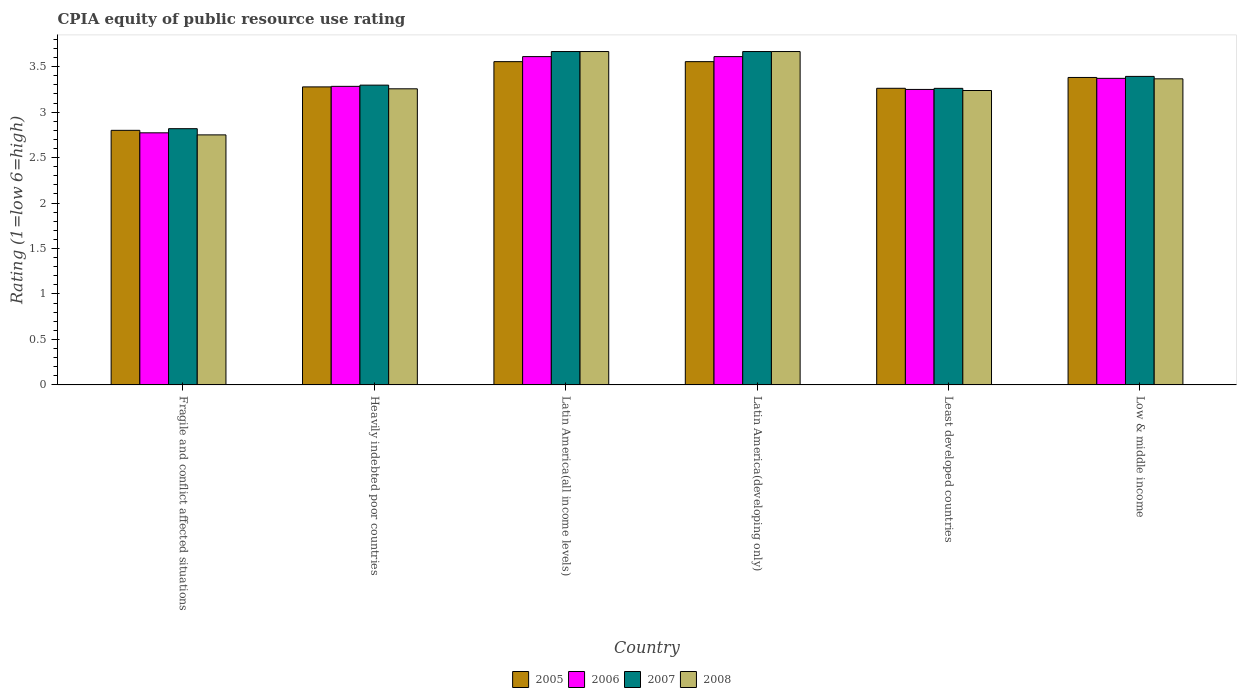How many groups of bars are there?
Give a very brief answer. 6. Are the number of bars per tick equal to the number of legend labels?
Keep it short and to the point. Yes. Are the number of bars on each tick of the X-axis equal?
Keep it short and to the point. Yes. How many bars are there on the 3rd tick from the right?
Ensure brevity in your answer.  4. What is the CPIA rating in 2006 in Latin America(all income levels)?
Your response must be concise. 3.61. Across all countries, what is the maximum CPIA rating in 2008?
Offer a terse response. 3.67. Across all countries, what is the minimum CPIA rating in 2008?
Provide a short and direct response. 2.75. In which country was the CPIA rating in 2006 maximum?
Offer a terse response. Latin America(all income levels). In which country was the CPIA rating in 2007 minimum?
Offer a terse response. Fragile and conflict affected situations. What is the total CPIA rating in 2006 in the graph?
Your answer should be very brief. 19.9. What is the difference between the CPIA rating in 2006 in Fragile and conflict affected situations and that in Least developed countries?
Give a very brief answer. -0.48. What is the difference between the CPIA rating in 2008 in Heavily indebted poor countries and the CPIA rating in 2005 in Fragile and conflict affected situations?
Your response must be concise. 0.46. What is the average CPIA rating in 2005 per country?
Offer a very short reply. 3.31. What is the difference between the CPIA rating of/in 2006 and CPIA rating of/in 2007 in Least developed countries?
Your response must be concise. -0.01. What is the ratio of the CPIA rating in 2008 in Fragile and conflict affected situations to that in Heavily indebted poor countries?
Provide a succinct answer. 0.84. Is the CPIA rating in 2007 in Least developed countries less than that in Low & middle income?
Provide a succinct answer. Yes. What is the difference between the highest and the second highest CPIA rating in 2007?
Make the answer very short. -0.27. What is the difference between the highest and the lowest CPIA rating in 2007?
Keep it short and to the point. 0.85. In how many countries, is the CPIA rating in 2006 greater than the average CPIA rating in 2006 taken over all countries?
Keep it short and to the point. 3. Is the sum of the CPIA rating in 2007 in Heavily indebted poor countries and Latin America(developing only) greater than the maximum CPIA rating in 2005 across all countries?
Your answer should be compact. Yes. What does the 4th bar from the left in Least developed countries represents?
Your answer should be compact. 2008. Does the graph contain grids?
Offer a terse response. No. Where does the legend appear in the graph?
Keep it short and to the point. Bottom center. How many legend labels are there?
Your answer should be very brief. 4. What is the title of the graph?
Ensure brevity in your answer.  CPIA equity of public resource use rating. Does "2012" appear as one of the legend labels in the graph?
Provide a short and direct response. No. What is the label or title of the Y-axis?
Your response must be concise. Rating (1=low 6=high). What is the Rating (1=low 6=high) in 2005 in Fragile and conflict affected situations?
Keep it short and to the point. 2.8. What is the Rating (1=low 6=high) in 2006 in Fragile and conflict affected situations?
Provide a succinct answer. 2.77. What is the Rating (1=low 6=high) in 2007 in Fragile and conflict affected situations?
Your answer should be very brief. 2.82. What is the Rating (1=low 6=high) in 2008 in Fragile and conflict affected situations?
Offer a terse response. 2.75. What is the Rating (1=low 6=high) in 2005 in Heavily indebted poor countries?
Make the answer very short. 3.28. What is the Rating (1=low 6=high) in 2006 in Heavily indebted poor countries?
Your answer should be very brief. 3.28. What is the Rating (1=low 6=high) of 2007 in Heavily indebted poor countries?
Your answer should be very brief. 3.3. What is the Rating (1=low 6=high) of 2008 in Heavily indebted poor countries?
Offer a very short reply. 3.26. What is the Rating (1=low 6=high) in 2005 in Latin America(all income levels)?
Give a very brief answer. 3.56. What is the Rating (1=low 6=high) in 2006 in Latin America(all income levels)?
Offer a very short reply. 3.61. What is the Rating (1=low 6=high) in 2007 in Latin America(all income levels)?
Offer a terse response. 3.67. What is the Rating (1=low 6=high) in 2008 in Latin America(all income levels)?
Keep it short and to the point. 3.67. What is the Rating (1=low 6=high) in 2005 in Latin America(developing only)?
Give a very brief answer. 3.56. What is the Rating (1=low 6=high) of 2006 in Latin America(developing only)?
Offer a terse response. 3.61. What is the Rating (1=low 6=high) of 2007 in Latin America(developing only)?
Give a very brief answer. 3.67. What is the Rating (1=low 6=high) in 2008 in Latin America(developing only)?
Your answer should be compact. 3.67. What is the Rating (1=low 6=high) of 2005 in Least developed countries?
Give a very brief answer. 3.26. What is the Rating (1=low 6=high) in 2006 in Least developed countries?
Give a very brief answer. 3.25. What is the Rating (1=low 6=high) of 2007 in Least developed countries?
Your response must be concise. 3.26. What is the Rating (1=low 6=high) in 2008 in Least developed countries?
Your response must be concise. 3.24. What is the Rating (1=low 6=high) in 2005 in Low & middle income?
Make the answer very short. 3.38. What is the Rating (1=low 6=high) of 2006 in Low & middle income?
Your answer should be very brief. 3.37. What is the Rating (1=low 6=high) in 2007 in Low & middle income?
Your response must be concise. 3.39. What is the Rating (1=low 6=high) of 2008 in Low & middle income?
Offer a very short reply. 3.37. Across all countries, what is the maximum Rating (1=low 6=high) in 2005?
Offer a terse response. 3.56. Across all countries, what is the maximum Rating (1=low 6=high) of 2006?
Your answer should be very brief. 3.61. Across all countries, what is the maximum Rating (1=low 6=high) in 2007?
Your answer should be very brief. 3.67. Across all countries, what is the maximum Rating (1=low 6=high) in 2008?
Give a very brief answer. 3.67. Across all countries, what is the minimum Rating (1=low 6=high) in 2006?
Keep it short and to the point. 2.77. Across all countries, what is the minimum Rating (1=low 6=high) of 2007?
Keep it short and to the point. 2.82. Across all countries, what is the minimum Rating (1=low 6=high) of 2008?
Ensure brevity in your answer.  2.75. What is the total Rating (1=low 6=high) of 2005 in the graph?
Keep it short and to the point. 19.83. What is the total Rating (1=low 6=high) of 2006 in the graph?
Ensure brevity in your answer.  19.9. What is the total Rating (1=low 6=high) of 2007 in the graph?
Provide a short and direct response. 20.1. What is the total Rating (1=low 6=high) of 2008 in the graph?
Keep it short and to the point. 19.94. What is the difference between the Rating (1=low 6=high) of 2005 in Fragile and conflict affected situations and that in Heavily indebted poor countries?
Your answer should be compact. -0.48. What is the difference between the Rating (1=low 6=high) of 2006 in Fragile and conflict affected situations and that in Heavily indebted poor countries?
Offer a terse response. -0.51. What is the difference between the Rating (1=low 6=high) of 2007 in Fragile and conflict affected situations and that in Heavily indebted poor countries?
Offer a very short reply. -0.48. What is the difference between the Rating (1=low 6=high) in 2008 in Fragile and conflict affected situations and that in Heavily indebted poor countries?
Offer a very short reply. -0.51. What is the difference between the Rating (1=low 6=high) of 2005 in Fragile and conflict affected situations and that in Latin America(all income levels)?
Your response must be concise. -0.76. What is the difference between the Rating (1=low 6=high) in 2006 in Fragile and conflict affected situations and that in Latin America(all income levels)?
Offer a terse response. -0.84. What is the difference between the Rating (1=low 6=high) in 2007 in Fragile and conflict affected situations and that in Latin America(all income levels)?
Your response must be concise. -0.85. What is the difference between the Rating (1=low 6=high) of 2008 in Fragile and conflict affected situations and that in Latin America(all income levels)?
Your response must be concise. -0.92. What is the difference between the Rating (1=low 6=high) of 2005 in Fragile and conflict affected situations and that in Latin America(developing only)?
Your answer should be very brief. -0.76. What is the difference between the Rating (1=low 6=high) of 2006 in Fragile and conflict affected situations and that in Latin America(developing only)?
Give a very brief answer. -0.84. What is the difference between the Rating (1=low 6=high) of 2007 in Fragile and conflict affected situations and that in Latin America(developing only)?
Offer a very short reply. -0.85. What is the difference between the Rating (1=low 6=high) in 2008 in Fragile and conflict affected situations and that in Latin America(developing only)?
Offer a very short reply. -0.92. What is the difference between the Rating (1=low 6=high) in 2005 in Fragile and conflict affected situations and that in Least developed countries?
Offer a very short reply. -0.46. What is the difference between the Rating (1=low 6=high) in 2006 in Fragile and conflict affected situations and that in Least developed countries?
Provide a short and direct response. -0.48. What is the difference between the Rating (1=low 6=high) of 2007 in Fragile and conflict affected situations and that in Least developed countries?
Keep it short and to the point. -0.44. What is the difference between the Rating (1=low 6=high) in 2008 in Fragile and conflict affected situations and that in Least developed countries?
Your answer should be compact. -0.49. What is the difference between the Rating (1=low 6=high) in 2005 in Fragile and conflict affected situations and that in Low & middle income?
Your answer should be very brief. -0.58. What is the difference between the Rating (1=low 6=high) in 2006 in Fragile and conflict affected situations and that in Low & middle income?
Provide a short and direct response. -0.6. What is the difference between the Rating (1=low 6=high) in 2007 in Fragile and conflict affected situations and that in Low & middle income?
Offer a very short reply. -0.58. What is the difference between the Rating (1=low 6=high) of 2008 in Fragile and conflict affected situations and that in Low & middle income?
Provide a succinct answer. -0.62. What is the difference between the Rating (1=low 6=high) of 2005 in Heavily indebted poor countries and that in Latin America(all income levels)?
Your answer should be very brief. -0.28. What is the difference between the Rating (1=low 6=high) in 2006 in Heavily indebted poor countries and that in Latin America(all income levels)?
Your answer should be very brief. -0.33. What is the difference between the Rating (1=low 6=high) of 2007 in Heavily indebted poor countries and that in Latin America(all income levels)?
Offer a terse response. -0.37. What is the difference between the Rating (1=low 6=high) in 2008 in Heavily indebted poor countries and that in Latin America(all income levels)?
Your answer should be very brief. -0.41. What is the difference between the Rating (1=low 6=high) of 2005 in Heavily indebted poor countries and that in Latin America(developing only)?
Offer a very short reply. -0.28. What is the difference between the Rating (1=low 6=high) in 2006 in Heavily indebted poor countries and that in Latin America(developing only)?
Your answer should be very brief. -0.33. What is the difference between the Rating (1=low 6=high) in 2007 in Heavily indebted poor countries and that in Latin America(developing only)?
Keep it short and to the point. -0.37. What is the difference between the Rating (1=low 6=high) in 2008 in Heavily indebted poor countries and that in Latin America(developing only)?
Offer a terse response. -0.41. What is the difference between the Rating (1=low 6=high) in 2005 in Heavily indebted poor countries and that in Least developed countries?
Offer a very short reply. 0.02. What is the difference between the Rating (1=low 6=high) in 2006 in Heavily indebted poor countries and that in Least developed countries?
Your answer should be very brief. 0.03. What is the difference between the Rating (1=low 6=high) in 2007 in Heavily indebted poor countries and that in Least developed countries?
Your response must be concise. 0.04. What is the difference between the Rating (1=low 6=high) of 2008 in Heavily indebted poor countries and that in Least developed countries?
Give a very brief answer. 0.02. What is the difference between the Rating (1=low 6=high) in 2005 in Heavily indebted poor countries and that in Low & middle income?
Provide a short and direct response. -0.1. What is the difference between the Rating (1=low 6=high) in 2006 in Heavily indebted poor countries and that in Low & middle income?
Offer a very short reply. -0.09. What is the difference between the Rating (1=low 6=high) in 2007 in Heavily indebted poor countries and that in Low & middle income?
Offer a terse response. -0.1. What is the difference between the Rating (1=low 6=high) of 2008 in Heavily indebted poor countries and that in Low & middle income?
Your answer should be compact. -0.11. What is the difference between the Rating (1=low 6=high) in 2005 in Latin America(all income levels) and that in Latin America(developing only)?
Offer a terse response. 0. What is the difference between the Rating (1=low 6=high) of 2006 in Latin America(all income levels) and that in Latin America(developing only)?
Offer a very short reply. 0. What is the difference between the Rating (1=low 6=high) of 2007 in Latin America(all income levels) and that in Latin America(developing only)?
Your answer should be very brief. 0. What is the difference between the Rating (1=low 6=high) in 2005 in Latin America(all income levels) and that in Least developed countries?
Provide a short and direct response. 0.29. What is the difference between the Rating (1=low 6=high) of 2006 in Latin America(all income levels) and that in Least developed countries?
Provide a succinct answer. 0.36. What is the difference between the Rating (1=low 6=high) in 2007 in Latin America(all income levels) and that in Least developed countries?
Offer a terse response. 0.4. What is the difference between the Rating (1=low 6=high) of 2008 in Latin America(all income levels) and that in Least developed countries?
Give a very brief answer. 0.43. What is the difference between the Rating (1=low 6=high) in 2005 in Latin America(all income levels) and that in Low & middle income?
Keep it short and to the point. 0.17. What is the difference between the Rating (1=low 6=high) of 2006 in Latin America(all income levels) and that in Low & middle income?
Your response must be concise. 0.24. What is the difference between the Rating (1=low 6=high) in 2007 in Latin America(all income levels) and that in Low & middle income?
Your response must be concise. 0.27. What is the difference between the Rating (1=low 6=high) of 2008 in Latin America(all income levels) and that in Low & middle income?
Provide a succinct answer. 0.3. What is the difference between the Rating (1=low 6=high) in 2005 in Latin America(developing only) and that in Least developed countries?
Provide a short and direct response. 0.29. What is the difference between the Rating (1=low 6=high) in 2006 in Latin America(developing only) and that in Least developed countries?
Give a very brief answer. 0.36. What is the difference between the Rating (1=low 6=high) of 2007 in Latin America(developing only) and that in Least developed countries?
Ensure brevity in your answer.  0.4. What is the difference between the Rating (1=low 6=high) in 2008 in Latin America(developing only) and that in Least developed countries?
Your answer should be compact. 0.43. What is the difference between the Rating (1=low 6=high) in 2005 in Latin America(developing only) and that in Low & middle income?
Offer a very short reply. 0.17. What is the difference between the Rating (1=low 6=high) in 2006 in Latin America(developing only) and that in Low & middle income?
Your answer should be very brief. 0.24. What is the difference between the Rating (1=low 6=high) in 2007 in Latin America(developing only) and that in Low & middle income?
Your answer should be very brief. 0.27. What is the difference between the Rating (1=low 6=high) of 2008 in Latin America(developing only) and that in Low & middle income?
Ensure brevity in your answer.  0.3. What is the difference between the Rating (1=low 6=high) in 2005 in Least developed countries and that in Low & middle income?
Your answer should be compact. -0.12. What is the difference between the Rating (1=low 6=high) of 2006 in Least developed countries and that in Low & middle income?
Keep it short and to the point. -0.12. What is the difference between the Rating (1=low 6=high) in 2007 in Least developed countries and that in Low & middle income?
Offer a terse response. -0.13. What is the difference between the Rating (1=low 6=high) of 2008 in Least developed countries and that in Low & middle income?
Keep it short and to the point. -0.13. What is the difference between the Rating (1=low 6=high) in 2005 in Fragile and conflict affected situations and the Rating (1=low 6=high) in 2006 in Heavily indebted poor countries?
Offer a terse response. -0.48. What is the difference between the Rating (1=low 6=high) in 2005 in Fragile and conflict affected situations and the Rating (1=low 6=high) in 2007 in Heavily indebted poor countries?
Ensure brevity in your answer.  -0.5. What is the difference between the Rating (1=low 6=high) in 2005 in Fragile and conflict affected situations and the Rating (1=low 6=high) in 2008 in Heavily indebted poor countries?
Offer a very short reply. -0.46. What is the difference between the Rating (1=low 6=high) of 2006 in Fragile and conflict affected situations and the Rating (1=low 6=high) of 2007 in Heavily indebted poor countries?
Make the answer very short. -0.52. What is the difference between the Rating (1=low 6=high) of 2006 in Fragile and conflict affected situations and the Rating (1=low 6=high) of 2008 in Heavily indebted poor countries?
Keep it short and to the point. -0.48. What is the difference between the Rating (1=low 6=high) of 2007 in Fragile and conflict affected situations and the Rating (1=low 6=high) of 2008 in Heavily indebted poor countries?
Provide a succinct answer. -0.44. What is the difference between the Rating (1=low 6=high) of 2005 in Fragile and conflict affected situations and the Rating (1=low 6=high) of 2006 in Latin America(all income levels)?
Keep it short and to the point. -0.81. What is the difference between the Rating (1=low 6=high) in 2005 in Fragile and conflict affected situations and the Rating (1=low 6=high) in 2007 in Latin America(all income levels)?
Make the answer very short. -0.87. What is the difference between the Rating (1=low 6=high) of 2005 in Fragile and conflict affected situations and the Rating (1=low 6=high) of 2008 in Latin America(all income levels)?
Make the answer very short. -0.87. What is the difference between the Rating (1=low 6=high) in 2006 in Fragile and conflict affected situations and the Rating (1=low 6=high) in 2007 in Latin America(all income levels)?
Make the answer very short. -0.89. What is the difference between the Rating (1=low 6=high) in 2006 in Fragile and conflict affected situations and the Rating (1=low 6=high) in 2008 in Latin America(all income levels)?
Your answer should be very brief. -0.89. What is the difference between the Rating (1=low 6=high) in 2007 in Fragile and conflict affected situations and the Rating (1=low 6=high) in 2008 in Latin America(all income levels)?
Provide a short and direct response. -0.85. What is the difference between the Rating (1=low 6=high) in 2005 in Fragile and conflict affected situations and the Rating (1=low 6=high) in 2006 in Latin America(developing only)?
Keep it short and to the point. -0.81. What is the difference between the Rating (1=low 6=high) of 2005 in Fragile and conflict affected situations and the Rating (1=low 6=high) of 2007 in Latin America(developing only)?
Provide a short and direct response. -0.87. What is the difference between the Rating (1=low 6=high) in 2005 in Fragile and conflict affected situations and the Rating (1=low 6=high) in 2008 in Latin America(developing only)?
Give a very brief answer. -0.87. What is the difference between the Rating (1=low 6=high) in 2006 in Fragile and conflict affected situations and the Rating (1=low 6=high) in 2007 in Latin America(developing only)?
Give a very brief answer. -0.89. What is the difference between the Rating (1=low 6=high) in 2006 in Fragile and conflict affected situations and the Rating (1=low 6=high) in 2008 in Latin America(developing only)?
Make the answer very short. -0.89. What is the difference between the Rating (1=low 6=high) of 2007 in Fragile and conflict affected situations and the Rating (1=low 6=high) of 2008 in Latin America(developing only)?
Provide a succinct answer. -0.85. What is the difference between the Rating (1=low 6=high) in 2005 in Fragile and conflict affected situations and the Rating (1=low 6=high) in 2006 in Least developed countries?
Ensure brevity in your answer.  -0.45. What is the difference between the Rating (1=low 6=high) in 2005 in Fragile and conflict affected situations and the Rating (1=low 6=high) in 2007 in Least developed countries?
Your answer should be compact. -0.46. What is the difference between the Rating (1=low 6=high) in 2005 in Fragile and conflict affected situations and the Rating (1=low 6=high) in 2008 in Least developed countries?
Give a very brief answer. -0.44. What is the difference between the Rating (1=low 6=high) of 2006 in Fragile and conflict affected situations and the Rating (1=low 6=high) of 2007 in Least developed countries?
Offer a very short reply. -0.49. What is the difference between the Rating (1=low 6=high) of 2006 in Fragile and conflict affected situations and the Rating (1=low 6=high) of 2008 in Least developed countries?
Keep it short and to the point. -0.47. What is the difference between the Rating (1=low 6=high) in 2007 in Fragile and conflict affected situations and the Rating (1=low 6=high) in 2008 in Least developed countries?
Give a very brief answer. -0.42. What is the difference between the Rating (1=low 6=high) of 2005 in Fragile and conflict affected situations and the Rating (1=low 6=high) of 2006 in Low & middle income?
Your answer should be compact. -0.57. What is the difference between the Rating (1=low 6=high) in 2005 in Fragile and conflict affected situations and the Rating (1=low 6=high) in 2007 in Low & middle income?
Your answer should be very brief. -0.59. What is the difference between the Rating (1=low 6=high) in 2005 in Fragile and conflict affected situations and the Rating (1=low 6=high) in 2008 in Low & middle income?
Make the answer very short. -0.57. What is the difference between the Rating (1=low 6=high) of 2006 in Fragile and conflict affected situations and the Rating (1=low 6=high) of 2007 in Low & middle income?
Make the answer very short. -0.62. What is the difference between the Rating (1=low 6=high) of 2006 in Fragile and conflict affected situations and the Rating (1=low 6=high) of 2008 in Low & middle income?
Your answer should be compact. -0.59. What is the difference between the Rating (1=low 6=high) in 2007 in Fragile and conflict affected situations and the Rating (1=low 6=high) in 2008 in Low & middle income?
Offer a terse response. -0.55. What is the difference between the Rating (1=low 6=high) in 2005 in Heavily indebted poor countries and the Rating (1=low 6=high) in 2007 in Latin America(all income levels)?
Offer a terse response. -0.39. What is the difference between the Rating (1=low 6=high) in 2005 in Heavily indebted poor countries and the Rating (1=low 6=high) in 2008 in Latin America(all income levels)?
Provide a short and direct response. -0.39. What is the difference between the Rating (1=low 6=high) in 2006 in Heavily indebted poor countries and the Rating (1=low 6=high) in 2007 in Latin America(all income levels)?
Offer a very short reply. -0.38. What is the difference between the Rating (1=low 6=high) in 2006 in Heavily indebted poor countries and the Rating (1=low 6=high) in 2008 in Latin America(all income levels)?
Your response must be concise. -0.38. What is the difference between the Rating (1=low 6=high) in 2007 in Heavily indebted poor countries and the Rating (1=low 6=high) in 2008 in Latin America(all income levels)?
Provide a short and direct response. -0.37. What is the difference between the Rating (1=low 6=high) of 2005 in Heavily indebted poor countries and the Rating (1=low 6=high) of 2007 in Latin America(developing only)?
Provide a succinct answer. -0.39. What is the difference between the Rating (1=low 6=high) in 2005 in Heavily indebted poor countries and the Rating (1=low 6=high) in 2008 in Latin America(developing only)?
Your answer should be compact. -0.39. What is the difference between the Rating (1=low 6=high) of 2006 in Heavily indebted poor countries and the Rating (1=low 6=high) of 2007 in Latin America(developing only)?
Keep it short and to the point. -0.38. What is the difference between the Rating (1=low 6=high) of 2006 in Heavily indebted poor countries and the Rating (1=low 6=high) of 2008 in Latin America(developing only)?
Keep it short and to the point. -0.38. What is the difference between the Rating (1=low 6=high) in 2007 in Heavily indebted poor countries and the Rating (1=low 6=high) in 2008 in Latin America(developing only)?
Provide a short and direct response. -0.37. What is the difference between the Rating (1=low 6=high) of 2005 in Heavily indebted poor countries and the Rating (1=low 6=high) of 2006 in Least developed countries?
Keep it short and to the point. 0.03. What is the difference between the Rating (1=low 6=high) in 2005 in Heavily indebted poor countries and the Rating (1=low 6=high) in 2007 in Least developed countries?
Give a very brief answer. 0.02. What is the difference between the Rating (1=low 6=high) in 2005 in Heavily indebted poor countries and the Rating (1=low 6=high) in 2008 in Least developed countries?
Your response must be concise. 0.04. What is the difference between the Rating (1=low 6=high) of 2006 in Heavily indebted poor countries and the Rating (1=low 6=high) of 2007 in Least developed countries?
Make the answer very short. 0.02. What is the difference between the Rating (1=low 6=high) in 2006 in Heavily indebted poor countries and the Rating (1=low 6=high) in 2008 in Least developed countries?
Offer a terse response. 0.05. What is the difference between the Rating (1=low 6=high) of 2007 in Heavily indebted poor countries and the Rating (1=low 6=high) of 2008 in Least developed countries?
Keep it short and to the point. 0.06. What is the difference between the Rating (1=low 6=high) of 2005 in Heavily indebted poor countries and the Rating (1=low 6=high) of 2006 in Low & middle income?
Give a very brief answer. -0.09. What is the difference between the Rating (1=low 6=high) in 2005 in Heavily indebted poor countries and the Rating (1=low 6=high) in 2007 in Low & middle income?
Provide a short and direct response. -0.12. What is the difference between the Rating (1=low 6=high) of 2005 in Heavily indebted poor countries and the Rating (1=low 6=high) of 2008 in Low & middle income?
Ensure brevity in your answer.  -0.09. What is the difference between the Rating (1=low 6=high) in 2006 in Heavily indebted poor countries and the Rating (1=low 6=high) in 2007 in Low & middle income?
Provide a succinct answer. -0.11. What is the difference between the Rating (1=low 6=high) of 2006 in Heavily indebted poor countries and the Rating (1=low 6=high) of 2008 in Low & middle income?
Your answer should be very brief. -0.08. What is the difference between the Rating (1=low 6=high) of 2007 in Heavily indebted poor countries and the Rating (1=low 6=high) of 2008 in Low & middle income?
Offer a very short reply. -0.07. What is the difference between the Rating (1=low 6=high) of 2005 in Latin America(all income levels) and the Rating (1=low 6=high) of 2006 in Latin America(developing only)?
Keep it short and to the point. -0.06. What is the difference between the Rating (1=low 6=high) of 2005 in Latin America(all income levels) and the Rating (1=low 6=high) of 2007 in Latin America(developing only)?
Offer a very short reply. -0.11. What is the difference between the Rating (1=low 6=high) in 2005 in Latin America(all income levels) and the Rating (1=low 6=high) in 2008 in Latin America(developing only)?
Keep it short and to the point. -0.11. What is the difference between the Rating (1=low 6=high) in 2006 in Latin America(all income levels) and the Rating (1=low 6=high) in 2007 in Latin America(developing only)?
Ensure brevity in your answer.  -0.06. What is the difference between the Rating (1=low 6=high) of 2006 in Latin America(all income levels) and the Rating (1=low 6=high) of 2008 in Latin America(developing only)?
Your response must be concise. -0.06. What is the difference between the Rating (1=low 6=high) in 2007 in Latin America(all income levels) and the Rating (1=low 6=high) in 2008 in Latin America(developing only)?
Ensure brevity in your answer.  0. What is the difference between the Rating (1=low 6=high) in 2005 in Latin America(all income levels) and the Rating (1=low 6=high) in 2006 in Least developed countries?
Your answer should be very brief. 0.31. What is the difference between the Rating (1=low 6=high) in 2005 in Latin America(all income levels) and the Rating (1=low 6=high) in 2007 in Least developed countries?
Your answer should be very brief. 0.29. What is the difference between the Rating (1=low 6=high) in 2005 in Latin America(all income levels) and the Rating (1=low 6=high) in 2008 in Least developed countries?
Offer a very short reply. 0.32. What is the difference between the Rating (1=low 6=high) in 2006 in Latin America(all income levels) and the Rating (1=low 6=high) in 2007 in Least developed countries?
Your answer should be compact. 0.35. What is the difference between the Rating (1=low 6=high) of 2006 in Latin America(all income levels) and the Rating (1=low 6=high) of 2008 in Least developed countries?
Provide a succinct answer. 0.37. What is the difference between the Rating (1=low 6=high) of 2007 in Latin America(all income levels) and the Rating (1=low 6=high) of 2008 in Least developed countries?
Make the answer very short. 0.43. What is the difference between the Rating (1=low 6=high) in 2005 in Latin America(all income levels) and the Rating (1=low 6=high) in 2006 in Low & middle income?
Your answer should be compact. 0.18. What is the difference between the Rating (1=low 6=high) of 2005 in Latin America(all income levels) and the Rating (1=low 6=high) of 2007 in Low & middle income?
Your answer should be compact. 0.16. What is the difference between the Rating (1=low 6=high) of 2005 in Latin America(all income levels) and the Rating (1=low 6=high) of 2008 in Low & middle income?
Your answer should be very brief. 0.19. What is the difference between the Rating (1=low 6=high) in 2006 in Latin America(all income levels) and the Rating (1=low 6=high) in 2007 in Low & middle income?
Your answer should be very brief. 0.22. What is the difference between the Rating (1=low 6=high) in 2006 in Latin America(all income levels) and the Rating (1=low 6=high) in 2008 in Low & middle income?
Offer a very short reply. 0.24. What is the difference between the Rating (1=low 6=high) of 2005 in Latin America(developing only) and the Rating (1=low 6=high) of 2006 in Least developed countries?
Offer a terse response. 0.31. What is the difference between the Rating (1=low 6=high) of 2005 in Latin America(developing only) and the Rating (1=low 6=high) of 2007 in Least developed countries?
Ensure brevity in your answer.  0.29. What is the difference between the Rating (1=low 6=high) of 2005 in Latin America(developing only) and the Rating (1=low 6=high) of 2008 in Least developed countries?
Ensure brevity in your answer.  0.32. What is the difference between the Rating (1=low 6=high) of 2006 in Latin America(developing only) and the Rating (1=low 6=high) of 2007 in Least developed countries?
Your answer should be compact. 0.35. What is the difference between the Rating (1=low 6=high) of 2006 in Latin America(developing only) and the Rating (1=low 6=high) of 2008 in Least developed countries?
Offer a very short reply. 0.37. What is the difference between the Rating (1=low 6=high) of 2007 in Latin America(developing only) and the Rating (1=low 6=high) of 2008 in Least developed countries?
Keep it short and to the point. 0.43. What is the difference between the Rating (1=low 6=high) in 2005 in Latin America(developing only) and the Rating (1=low 6=high) in 2006 in Low & middle income?
Your answer should be compact. 0.18. What is the difference between the Rating (1=low 6=high) in 2005 in Latin America(developing only) and the Rating (1=low 6=high) in 2007 in Low & middle income?
Ensure brevity in your answer.  0.16. What is the difference between the Rating (1=low 6=high) of 2005 in Latin America(developing only) and the Rating (1=low 6=high) of 2008 in Low & middle income?
Offer a terse response. 0.19. What is the difference between the Rating (1=low 6=high) of 2006 in Latin America(developing only) and the Rating (1=low 6=high) of 2007 in Low & middle income?
Offer a very short reply. 0.22. What is the difference between the Rating (1=low 6=high) in 2006 in Latin America(developing only) and the Rating (1=low 6=high) in 2008 in Low & middle income?
Your answer should be very brief. 0.24. What is the difference between the Rating (1=low 6=high) of 2007 in Latin America(developing only) and the Rating (1=low 6=high) of 2008 in Low & middle income?
Make the answer very short. 0.3. What is the difference between the Rating (1=low 6=high) in 2005 in Least developed countries and the Rating (1=low 6=high) in 2006 in Low & middle income?
Offer a terse response. -0.11. What is the difference between the Rating (1=low 6=high) in 2005 in Least developed countries and the Rating (1=low 6=high) in 2007 in Low & middle income?
Your answer should be compact. -0.13. What is the difference between the Rating (1=low 6=high) in 2005 in Least developed countries and the Rating (1=low 6=high) in 2008 in Low & middle income?
Your answer should be very brief. -0.1. What is the difference between the Rating (1=low 6=high) in 2006 in Least developed countries and the Rating (1=low 6=high) in 2007 in Low & middle income?
Provide a short and direct response. -0.14. What is the difference between the Rating (1=low 6=high) of 2006 in Least developed countries and the Rating (1=low 6=high) of 2008 in Low & middle income?
Your answer should be compact. -0.12. What is the difference between the Rating (1=low 6=high) of 2007 in Least developed countries and the Rating (1=low 6=high) of 2008 in Low & middle income?
Make the answer very short. -0.1. What is the average Rating (1=low 6=high) of 2005 per country?
Offer a very short reply. 3.31. What is the average Rating (1=low 6=high) of 2006 per country?
Offer a very short reply. 3.32. What is the average Rating (1=low 6=high) of 2007 per country?
Make the answer very short. 3.35. What is the average Rating (1=low 6=high) of 2008 per country?
Provide a succinct answer. 3.32. What is the difference between the Rating (1=low 6=high) in 2005 and Rating (1=low 6=high) in 2006 in Fragile and conflict affected situations?
Your response must be concise. 0.03. What is the difference between the Rating (1=low 6=high) of 2005 and Rating (1=low 6=high) of 2007 in Fragile and conflict affected situations?
Make the answer very short. -0.02. What is the difference between the Rating (1=low 6=high) of 2005 and Rating (1=low 6=high) of 2008 in Fragile and conflict affected situations?
Offer a terse response. 0.05. What is the difference between the Rating (1=low 6=high) of 2006 and Rating (1=low 6=high) of 2007 in Fragile and conflict affected situations?
Offer a very short reply. -0.05. What is the difference between the Rating (1=low 6=high) of 2006 and Rating (1=low 6=high) of 2008 in Fragile and conflict affected situations?
Provide a succinct answer. 0.02. What is the difference between the Rating (1=low 6=high) in 2007 and Rating (1=low 6=high) in 2008 in Fragile and conflict affected situations?
Your answer should be compact. 0.07. What is the difference between the Rating (1=low 6=high) of 2005 and Rating (1=low 6=high) of 2006 in Heavily indebted poor countries?
Ensure brevity in your answer.  -0.01. What is the difference between the Rating (1=low 6=high) of 2005 and Rating (1=low 6=high) of 2007 in Heavily indebted poor countries?
Your answer should be very brief. -0.02. What is the difference between the Rating (1=low 6=high) of 2005 and Rating (1=low 6=high) of 2008 in Heavily indebted poor countries?
Your response must be concise. 0.02. What is the difference between the Rating (1=low 6=high) in 2006 and Rating (1=low 6=high) in 2007 in Heavily indebted poor countries?
Give a very brief answer. -0.01. What is the difference between the Rating (1=low 6=high) in 2006 and Rating (1=low 6=high) in 2008 in Heavily indebted poor countries?
Your response must be concise. 0.03. What is the difference between the Rating (1=low 6=high) of 2007 and Rating (1=low 6=high) of 2008 in Heavily indebted poor countries?
Offer a terse response. 0.04. What is the difference between the Rating (1=low 6=high) in 2005 and Rating (1=low 6=high) in 2006 in Latin America(all income levels)?
Provide a succinct answer. -0.06. What is the difference between the Rating (1=low 6=high) in 2005 and Rating (1=low 6=high) in 2007 in Latin America(all income levels)?
Offer a very short reply. -0.11. What is the difference between the Rating (1=low 6=high) in 2005 and Rating (1=low 6=high) in 2008 in Latin America(all income levels)?
Give a very brief answer. -0.11. What is the difference between the Rating (1=low 6=high) of 2006 and Rating (1=low 6=high) of 2007 in Latin America(all income levels)?
Your answer should be very brief. -0.06. What is the difference between the Rating (1=low 6=high) in 2006 and Rating (1=low 6=high) in 2008 in Latin America(all income levels)?
Your answer should be compact. -0.06. What is the difference between the Rating (1=low 6=high) in 2005 and Rating (1=low 6=high) in 2006 in Latin America(developing only)?
Offer a very short reply. -0.06. What is the difference between the Rating (1=low 6=high) in 2005 and Rating (1=low 6=high) in 2007 in Latin America(developing only)?
Your response must be concise. -0.11. What is the difference between the Rating (1=low 6=high) in 2005 and Rating (1=low 6=high) in 2008 in Latin America(developing only)?
Ensure brevity in your answer.  -0.11. What is the difference between the Rating (1=low 6=high) in 2006 and Rating (1=low 6=high) in 2007 in Latin America(developing only)?
Offer a very short reply. -0.06. What is the difference between the Rating (1=low 6=high) of 2006 and Rating (1=low 6=high) of 2008 in Latin America(developing only)?
Keep it short and to the point. -0.06. What is the difference between the Rating (1=low 6=high) of 2007 and Rating (1=low 6=high) of 2008 in Latin America(developing only)?
Make the answer very short. 0. What is the difference between the Rating (1=low 6=high) of 2005 and Rating (1=low 6=high) of 2006 in Least developed countries?
Your response must be concise. 0.01. What is the difference between the Rating (1=low 6=high) of 2005 and Rating (1=low 6=high) of 2007 in Least developed countries?
Make the answer very short. 0. What is the difference between the Rating (1=low 6=high) of 2005 and Rating (1=low 6=high) of 2008 in Least developed countries?
Offer a terse response. 0.02. What is the difference between the Rating (1=low 6=high) in 2006 and Rating (1=low 6=high) in 2007 in Least developed countries?
Make the answer very short. -0.01. What is the difference between the Rating (1=low 6=high) of 2006 and Rating (1=low 6=high) of 2008 in Least developed countries?
Offer a very short reply. 0.01. What is the difference between the Rating (1=low 6=high) of 2007 and Rating (1=low 6=high) of 2008 in Least developed countries?
Offer a very short reply. 0.02. What is the difference between the Rating (1=low 6=high) of 2005 and Rating (1=low 6=high) of 2006 in Low & middle income?
Give a very brief answer. 0.01. What is the difference between the Rating (1=low 6=high) of 2005 and Rating (1=low 6=high) of 2007 in Low & middle income?
Make the answer very short. -0.01. What is the difference between the Rating (1=low 6=high) in 2005 and Rating (1=low 6=high) in 2008 in Low & middle income?
Your answer should be compact. 0.01. What is the difference between the Rating (1=low 6=high) in 2006 and Rating (1=low 6=high) in 2007 in Low & middle income?
Provide a short and direct response. -0.02. What is the difference between the Rating (1=low 6=high) in 2006 and Rating (1=low 6=high) in 2008 in Low & middle income?
Ensure brevity in your answer.  0.01. What is the difference between the Rating (1=low 6=high) in 2007 and Rating (1=low 6=high) in 2008 in Low & middle income?
Your answer should be very brief. 0.03. What is the ratio of the Rating (1=low 6=high) of 2005 in Fragile and conflict affected situations to that in Heavily indebted poor countries?
Keep it short and to the point. 0.85. What is the ratio of the Rating (1=low 6=high) in 2006 in Fragile and conflict affected situations to that in Heavily indebted poor countries?
Keep it short and to the point. 0.84. What is the ratio of the Rating (1=low 6=high) of 2007 in Fragile and conflict affected situations to that in Heavily indebted poor countries?
Your response must be concise. 0.85. What is the ratio of the Rating (1=low 6=high) of 2008 in Fragile and conflict affected situations to that in Heavily indebted poor countries?
Provide a succinct answer. 0.84. What is the ratio of the Rating (1=low 6=high) in 2005 in Fragile and conflict affected situations to that in Latin America(all income levels)?
Your response must be concise. 0.79. What is the ratio of the Rating (1=low 6=high) in 2006 in Fragile and conflict affected situations to that in Latin America(all income levels)?
Give a very brief answer. 0.77. What is the ratio of the Rating (1=low 6=high) of 2007 in Fragile and conflict affected situations to that in Latin America(all income levels)?
Provide a succinct answer. 0.77. What is the ratio of the Rating (1=low 6=high) of 2008 in Fragile and conflict affected situations to that in Latin America(all income levels)?
Offer a terse response. 0.75. What is the ratio of the Rating (1=low 6=high) of 2005 in Fragile and conflict affected situations to that in Latin America(developing only)?
Ensure brevity in your answer.  0.79. What is the ratio of the Rating (1=low 6=high) in 2006 in Fragile and conflict affected situations to that in Latin America(developing only)?
Make the answer very short. 0.77. What is the ratio of the Rating (1=low 6=high) in 2007 in Fragile and conflict affected situations to that in Latin America(developing only)?
Provide a succinct answer. 0.77. What is the ratio of the Rating (1=low 6=high) of 2005 in Fragile and conflict affected situations to that in Least developed countries?
Offer a terse response. 0.86. What is the ratio of the Rating (1=low 6=high) of 2006 in Fragile and conflict affected situations to that in Least developed countries?
Your answer should be very brief. 0.85. What is the ratio of the Rating (1=low 6=high) of 2007 in Fragile and conflict affected situations to that in Least developed countries?
Your answer should be very brief. 0.86. What is the ratio of the Rating (1=low 6=high) in 2008 in Fragile and conflict affected situations to that in Least developed countries?
Your answer should be very brief. 0.85. What is the ratio of the Rating (1=low 6=high) in 2005 in Fragile and conflict affected situations to that in Low & middle income?
Keep it short and to the point. 0.83. What is the ratio of the Rating (1=low 6=high) in 2006 in Fragile and conflict affected situations to that in Low & middle income?
Offer a terse response. 0.82. What is the ratio of the Rating (1=low 6=high) in 2007 in Fragile and conflict affected situations to that in Low & middle income?
Your answer should be compact. 0.83. What is the ratio of the Rating (1=low 6=high) of 2008 in Fragile and conflict affected situations to that in Low & middle income?
Keep it short and to the point. 0.82. What is the ratio of the Rating (1=low 6=high) in 2005 in Heavily indebted poor countries to that in Latin America(all income levels)?
Keep it short and to the point. 0.92. What is the ratio of the Rating (1=low 6=high) in 2006 in Heavily indebted poor countries to that in Latin America(all income levels)?
Ensure brevity in your answer.  0.91. What is the ratio of the Rating (1=low 6=high) in 2007 in Heavily indebted poor countries to that in Latin America(all income levels)?
Give a very brief answer. 0.9. What is the ratio of the Rating (1=low 6=high) of 2008 in Heavily indebted poor countries to that in Latin America(all income levels)?
Ensure brevity in your answer.  0.89. What is the ratio of the Rating (1=low 6=high) in 2005 in Heavily indebted poor countries to that in Latin America(developing only)?
Your answer should be compact. 0.92. What is the ratio of the Rating (1=low 6=high) in 2006 in Heavily indebted poor countries to that in Latin America(developing only)?
Provide a short and direct response. 0.91. What is the ratio of the Rating (1=low 6=high) in 2007 in Heavily indebted poor countries to that in Latin America(developing only)?
Provide a succinct answer. 0.9. What is the ratio of the Rating (1=low 6=high) of 2008 in Heavily indebted poor countries to that in Latin America(developing only)?
Give a very brief answer. 0.89. What is the ratio of the Rating (1=low 6=high) of 2005 in Heavily indebted poor countries to that in Least developed countries?
Keep it short and to the point. 1. What is the ratio of the Rating (1=low 6=high) of 2006 in Heavily indebted poor countries to that in Least developed countries?
Your answer should be compact. 1.01. What is the ratio of the Rating (1=low 6=high) in 2007 in Heavily indebted poor countries to that in Least developed countries?
Offer a terse response. 1.01. What is the ratio of the Rating (1=low 6=high) of 2008 in Heavily indebted poor countries to that in Least developed countries?
Provide a succinct answer. 1.01. What is the ratio of the Rating (1=low 6=high) in 2005 in Heavily indebted poor countries to that in Low & middle income?
Keep it short and to the point. 0.97. What is the ratio of the Rating (1=low 6=high) of 2006 in Heavily indebted poor countries to that in Low & middle income?
Give a very brief answer. 0.97. What is the ratio of the Rating (1=low 6=high) in 2007 in Heavily indebted poor countries to that in Low & middle income?
Your answer should be very brief. 0.97. What is the ratio of the Rating (1=low 6=high) in 2008 in Heavily indebted poor countries to that in Low & middle income?
Keep it short and to the point. 0.97. What is the ratio of the Rating (1=low 6=high) in 2007 in Latin America(all income levels) to that in Latin America(developing only)?
Provide a short and direct response. 1. What is the ratio of the Rating (1=low 6=high) of 2008 in Latin America(all income levels) to that in Latin America(developing only)?
Keep it short and to the point. 1. What is the ratio of the Rating (1=low 6=high) in 2005 in Latin America(all income levels) to that in Least developed countries?
Ensure brevity in your answer.  1.09. What is the ratio of the Rating (1=low 6=high) in 2007 in Latin America(all income levels) to that in Least developed countries?
Offer a very short reply. 1.12. What is the ratio of the Rating (1=low 6=high) of 2008 in Latin America(all income levels) to that in Least developed countries?
Provide a short and direct response. 1.13. What is the ratio of the Rating (1=low 6=high) of 2005 in Latin America(all income levels) to that in Low & middle income?
Keep it short and to the point. 1.05. What is the ratio of the Rating (1=low 6=high) in 2006 in Latin America(all income levels) to that in Low & middle income?
Offer a terse response. 1.07. What is the ratio of the Rating (1=low 6=high) in 2007 in Latin America(all income levels) to that in Low & middle income?
Offer a terse response. 1.08. What is the ratio of the Rating (1=low 6=high) in 2008 in Latin America(all income levels) to that in Low & middle income?
Make the answer very short. 1.09. What is the ratio of the Rating (1=low 6=high) of 2005 in Latin America(developing only) to that in Least developed countries?
Offer a very short reply. 1.09. What is the ratio of the Rating (1=low 6=high) in 2007 in Latin America(developing only) to that in Least developed countries?
Your answer should be very brief. 1.12. What is the ratio of the Rating (1=low 6=high) in 2008 in Latin America(developing only) to that in Least developed countries?
Offer a very short reply. 1.13. What is the ratio of the Rating (1=low 6=high) in 2005 in Latin America(developing only) to that in Low & middle income?
Offer a terse response. 1.05. What is the ratio of the Rating (1=low 6=high) of 2006 in Latin America(developing only) to that in Low & middle income?
Your answer should be very brief. 1.07. What is the ratio of the Rating (1=low 6=high) of 2007 in Latin America(developing only) to that in Low & middle income?
Your response must be concise. 1.08. What is the ratio of the Rating (1=low 6=high) of 2008 in Latin America(developing only) to that in Low & middle income?
Your answer should be compact. 1.09. What is the ratio of the Rating (1=low 6=high) of 2005 in Least developed countries to that in Low & middle income?
Your answer should be compact. 0.96. What is the ratio of the Rating (1=low 6=high) of 2006 in Least developed countries to that in Low & middle income?
Offer a very short reply. 0.96. What is the ratio of the Rating (1=low 6=high) in 2007 in Least developed countries to that in Low & middle income?
Offer a very short reply. 0.96. What is the ratio of the Rating (1=low 6=high) of 2008 in Least developed countries to that in Low & middle income?
Give a very brief answer. 0.96. What is the difference between the highest and the second highest Rating (1=low 6=high) in 2005?
Provide a short and direct response. 0. What is the difference between the highest and the second highest Rating (1=low 6=high) of 2006?
Ensure brevity in your answer.  0. What is the difference between the highest and the lowest Rating (1=low 6=high) in 2005?
Offer a terse response. 0.76. What is the difference between the highest and the lowest Rating (1=low 6=high) of 2006?
Ensure brevity in your answer.  0.84. What is the difference between the highest and the lowest Rating (1=low 6=high) in 2007?
Your answer should be compact. 0.85. What is the difference between the highest and the lowest Rating (1=low 6=high) of 2008?
Offer a very short reply. 0.92. 